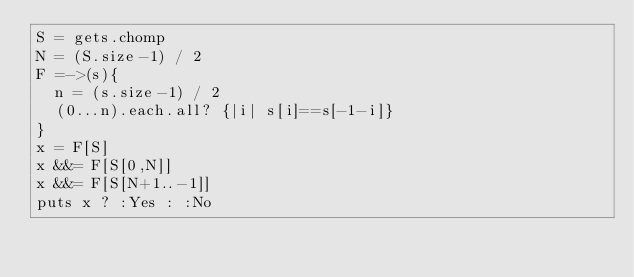Convert code to text. <code><loc_0><loc_0><loc_500><loc_500><_Ruby_>S = gets.chomp
N = (S.size-1) / 2
F =->(s){
  n = (s.size-1) / 2
  (0...n).each.all? {|i| s[i]==s[-1-i]}
}
x = F[S]
x &&= F[S[0,N]]
x &&= F[S[N+1..-1]]
puts x ? :Yes : :No</code> 